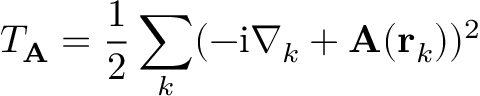Convert formula to latex. <formula><loc_0><loc_0><loc_500><loc_500>T _ { A } = \frac { 1 } { 2 } \sum _ { k } ( - i \nabla _ { k } + A ( r _ { k } ) ) ^ { 2 }</formula> 